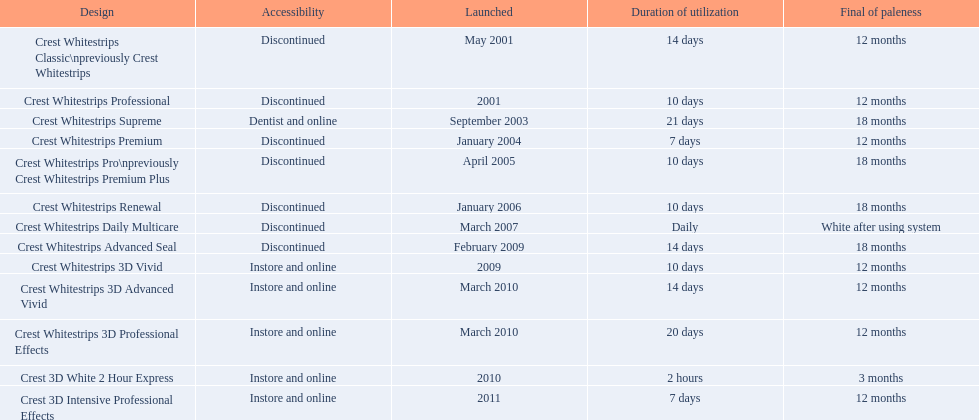Which models are still available? Crest Whitestrips Supreme, Crest Whitestrips 3D Vivid, Crest Whitestrips 3D Advanced Vivid, Crest Whitestrips 3D Professional Effects, Crest 3D White 2 Hour Express, Crest 3D Intensive Professional Effects. Of those, which were introduced prior to 2011? Crest Whitestrips Supreme, Crest Whitestrips 3D Vivid, Crest Whitestrips 3D Advanced Vivid, Crest Whitestrips 3D Professional Effects, Crest 3D White 2 Hour Express. Among those models, which ones had to be used at least 14 days? Crest Whitestrips Supreme, Crest Whitestrips 3D Advanced Vivid, Crest Whitestrips 3D Professional Effects. Which of those lasted longer than 12 months? Crest Whitestrips Supreme. 